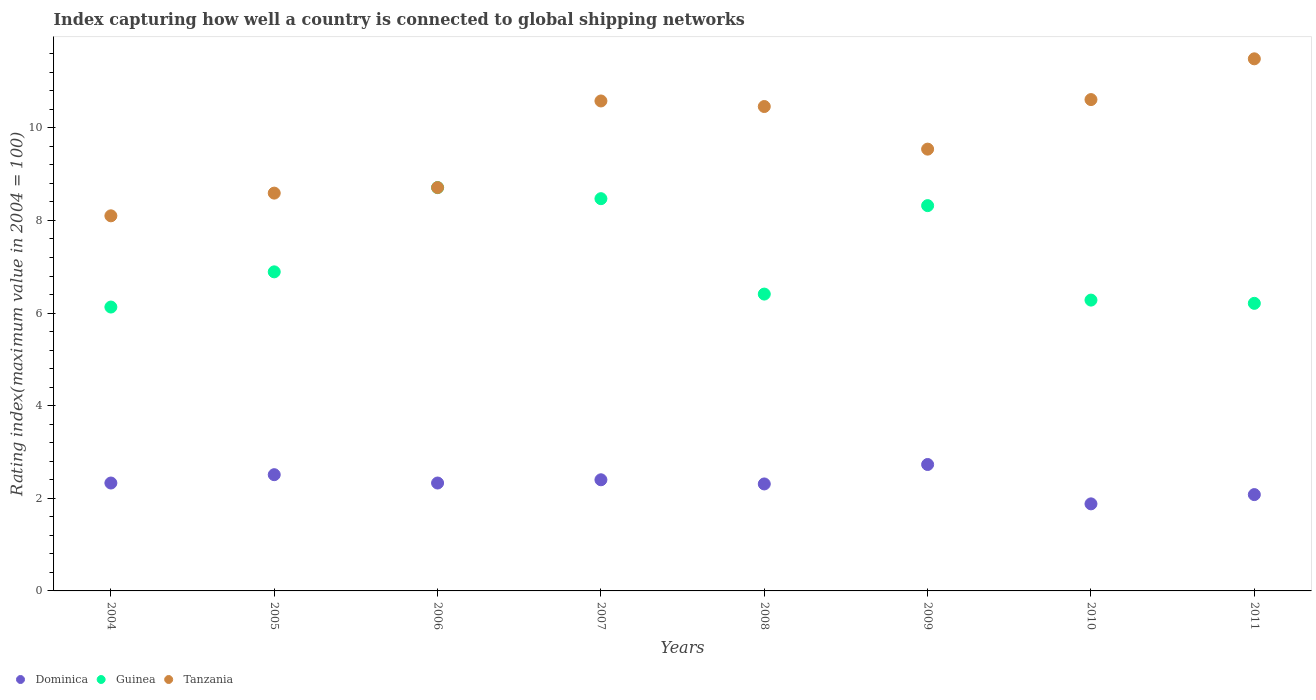How many different coloured dotlines are there?
Offer a terse response. 3. Is the number of dotlines equal to the number of legend labels?
Your answer should be compact. Yes. Across all years, what is the maximum rating index in Dominica?
Offer a very short reply. 2.73. Across all years, what is the minimum rating index in Guinea?
Make the answer very short. 6.13. In which year was the rating index in Guinea minimum?
Your answer should be very brief. 2004. What is the total rating index in Tanzania in the graph?
Keep it short and to the point. 78.08. What is the difference between the rating index in Tanzania in 2008 and that in 2011?
Your answer should be compact. -1.03. What is the difference between the rating index in Tanzania in 2006 and the rating index in Dominica in 2007?
Offer a terse response. 6.31. What is the average rating index in Tanzania per year?
Offer a terse response. 9.76. What is the ratio of the rating index in Guinea in 2006 to that in 2007?
Offer a terse response. 1.03. Is the rating index in Guinea in 2010 less than that in 2011?
Your answer should be compact. No. Is the difference between the rating index in Guinea in 2005 and 2011 greater than the difference between the rating index in Dominica in 2005 and 2011?
Make the answer very short. Yes. What is the difference between the highest and the second highest rating index in Guinea?
Your answer should be very brief. 0.24. What is the difference between the highest and the lowest rating index in Tanzania?
Ensure brevity in your answer.  3.39. In how many years, is the rating index in Dominica greater than the average rating index in Dominica taken over all years?
Your response must be concise. 5. Is it the case that in every year, the sum of the rating index in Dominica and rating index in Tanzania  is greater than the rating index in Guinea?
Offer a very short reply. Yes. Is the rating index in Guinea strictly less than the rating index in Dominica over the years?
Your answer should be very brief. No. How many years are there in the graph?
Ensure brevity in your answer.  8. What is the difference between two consecutive major ticks on the Y-axis?
Offer a very short reply. 2. Does the graph contain grids?
Keep it short and to the point. No. How are the legend labels stacked?
Provide a succinct answer. Horizontal. What is the title of the graph?
Offer a very short reply. Index capturing how well a country is connected to global shipping networks. What is the label or title of the Y-axis?
Keep it short and to the point. Rating index(maximum value in 2004 = 100). What is the Rating index(maximum value in 2004 = 100) in Dominica in 2004?
Provide a succinct answer. 2.33. What is the Rating index(maximum value in 2004 = 100) of Guinea in 2004?
Make the answer very short. 6.13. What is the Rating index(maximum value in 2004 = 100) of Tanzania in 2004?
Offer a very short reply. 8.1. What is the Rating index(maximum value in 2004 = 100) of Dominica in 2005?
Offer a very short reply. 2.51. What is the Rating index(maximum value in 2004 = 100) in Guinea in 2005?
Make the answer very short. 6.89. What is the Rating index(maximum value in 2004 = 100) in Tanzania in 2005?
Offer a terse response. 8.59. What is the Rating index(maximum value in 2004 = 100) in Dominica in 2006?
Keep it short and to the point. 2.33. What is the Rating index(maximum value in 2004 = 100) of Guinea in 2006?
Provide a short and direct response. 8.71. What is the Rating index(maximum value in 2004 = 100) in Tanzania in 2006?
Make the answer very short. 8.71. What is the Rating index(maximum value in 2004 = 100) in Dominica in 2007?
Offer a terse response. 2.4. What is the Rating index(maximum value in 2004 = 100) in Guinea in 2007?
Keep it short and to the point. 8.47. What is the Rating index(maximum value in 2004 = 100) of Tanzania in 2007?
Make the answer very short. 10.58. What is the Rating index(maximum value in 2004 = 100) of Dominica in 2008?
Ensure brevity in your answer.  2.31. What is the Rating index(maximum value in 2004 = 100) in Guinea in 2008?
Offer a very short reply. 6.41. What is the Rating index(maximum value in 2004 = 100) in Tanzania in 2008?
Your response must be concise. 10.46. What is the Rating index(maximum value in 2004 = 100) in Dominica in 2009?
Your answer should be very brief. 2.73. What is the Rating index(maximum value in 2004 = 100) in Guinea in 2009?
Your answer should be very brief. 8.32. What is the Rating index(maximum value in 2004 = 100) of Tanzania in 2009?
Give a very brief answer. 9.54. What is the Rating index(maximum value in 2004 = 100) of Dominica in 2010?
Offer a terse response. 1.88. What is the Rating index(maximum value in 2004 = 100) of Guinea in 2010?
Offer a terse response. 6.28. What is the Rating index(maximum value in 2004 = 100) of Tanzania in 2010?
Your answer should be compact. 10.61. What is the Rating index(maximum value in 2004 = 100) in Dominica in 2011?
Your answer should be very brief. 2.08. What is the Rating index(maximum value in 2004 = 100) in Guinea in 2011?
Your answer should be very brief. 6.21. What is the Rating index(maximum value in 2004 = 100) of Tanzania in 2011?
Your answer should be compact. 11.49. Across all years, what is the maximum Rating index(maximum value in 2004 = 100) of Dominica?
Keep it short and to the point. 2.73. Across all years, what is the maximum Rating index(maximum value in 2004 = 100) in Guinea?
Make the answer very short. 8.71. Across all years, what is the maximum Rating index(maximum value in 2004 = 100) of Tanzania?
Your answer should be very brief. 11.49. Across all years, what is the minimum Rating index(maximum value in 2004 = 100) of Dominica?
Offer a terse response. 1.88. Across all years, what is the minimum Rating index(maximum value in 2004 = 100) of Guinea?
Your answer should be compact. 6.13. What is the total Rating index(maximum value in 2004 = 100) in Dominica in the graph?
Make the answer very short. 18.57. What is the total Rating index(maximum value in 2004 = 100) of Guinea in the graph?
Provide a succinct answer. 57.42. What is the total Rating index(maximum value in 2004 = 100) in Tanzania in the graph?
Ensure brevity in your answer.  78.08. What is the difference between the Rating index(maximum value in 2004 = 100) of Dominica in 2004 and that in 2005?
Ensure brevity in your answer.  -0.18. What is the difference between the Rating index(maximum value in 2004 = 100) in Guinea in 2004 and that in 2005?
Your answer should be very brief. -0.76. What is the difference between the Rating index(maximum value in 2004 = 100) in Tanzania in 2004 and that in 2005?
Provide a succinct answer. -0.49. What is the difference between the Rating index(maximum value in 2004 = 100) of Dominica in 2004 and that in 2006?
Your answer should be very brief. 0. What is the difference between the Rating index(maximum value in 2004 = 100) in Guinea in 2004 and that in 2006?
Keep it short and to the point. -2.58. What is the difference between the Rating index(maximum value in 2004 = 100) of Tanzania in 2004 and that in 2006?
Ensure brevity in your answer.  -0.61. What is the difference between the Rating index(maximum value in 2004 = 100) in Dominica in 2004 and that in 2007?
Offer a terse response. -0.07. What is the difference between the Rating index(maximum value in 2004 = 100) of Guinea in 2004 and that in 2007?
Provide a short and direct response. -2.34. What is the difference between the Rating index(maximum value in 2004 = 100) of Tanzania in 2004 and that in 2007?
Provide a short and direct response. -2.48. What is the difference between the Rating index(maximum value in 2004 = 100) of Dominica in 2004 and that in 2008?
Ensure brevity in your answer.  0.02. What is the difference between the Rating index(maximum value in 2004 = 100) of Guinea in 2004 and that in 2008?
Offer a very short reply. -0.28. What is the difference between the Rating index(maximum value in 2004 = 100) in Tanzania in 2004 and that in 2008?
Keep it short and to the point. -2.36. What is the difference between the Rating index(maximum value in 2004 = 100) of Guinea in 2004 and that in 2009?
Your answer should be compact. -2.19. What is the difference between the Rating index(maximum value in 2004 = 100) of Tanzania in 2004 and that in 2009?
Offer a terse response. -1.44. What is the difference between the Rating index(maximum value in 2004 = 100) in Dominica in 2004 and that in 2010?
Provide a short and direct response. 0.45. What is the difference between the Rating index(maximum value in 2004 = 100) of Guinea in 2004 and that in 2010?
Ensure brevity in your answer.  -0.15. What is the difference between the Rating index(maximum value in 2004 = 100) in Tanzania in 2004 and that in 2010?
Make the answer very short. -2.51. What is the difference between the Rating index(maximum value in 2004 = 100) in Dominica in 2004 and that in 2011?
Keep it short and to the point. 0.25. What is the difference between the Rating index(maximum value in 2004 = 100) in Guinea in 2004 and that in 2011?
Provide a short and direct response. -0.08. What is the difference between the Rating index(maximum value in 2004 = 100) in Tanzania in 2004 and that in 2011?
Your answer should be compact. -3.39. What is the difference between the Rating index(maximum value in 2004 = 100) in Dominica in 2005 and that in 2006?
Ensure brevity in your answer.  0.18. What is the difference between the Rating index(maximum value in 2004 = 100) of Guinea in 2005 and that in 2006?
Provide a succinct answer. -1.82. What is the difference between the Rating index(maximum value in 2004 = 100) of Tanzania in 2005 and that in 2006?
Your answer should be compact. -0.12. What is the difference between the Rating index(maximum value in 2004 = 100) in Dominica in 2005 and that in 2007?
Provide a succinct answer. 0.11. What is the difference between the Rating index(maximum value in 2004 = 100) of Guinea in 2005 and that in 2007?
Your answer should be compact. -1.58. What is the difference between the Rating index(maximum value in 2004 = 100) of Tanzania in 2005 and that in 2007?
Offer a very short reply. -1.99. What is the difference between the Rating index(maximum value in 2004 = 100) of Guinea in 2005 and that in 2008?
Your answer should be very brief. 0.48. What is the difference between the Rating index(maximum value in 2004 = 100) in Tanzania in 2005 and that in 2008?
Your answer should be compact. -1.87. What is the difference between the Rating index(maximum value in 2004 = 100) in Dominica in 2005 and that in 2009?
Your response must be concise. -0.22. What is the difference between the Rating index(maximum value in 2004 = 100) in Guinea in 2005 and that in 2009?
Provide a short and direct response. -1.43. What is the difference between the Rating index(maximum value in 2004 = 100) in Tanzania in 2005 and that in 2009?
Provide a short and direct response. -0.95. What is the difference between the Rating index(maximum value in 2004 = 100) in Dominica in 2005 and that in 2010?
Keep it short and to the point. 0.63. What is the difference between the Rating index(maximum value in 2004 = 100) of Guinea in 2005 and that in 2010?
Your response must be concise. 0.61. What is the difference between the Rating index(maximum value in 2004 = 100) of Tanzania in 2005 and that in 2010?
Provide a short and direct response. -2.02. What is the difference between the Rating index(maximum value in 2004 = 100) in Dominica in 2005 and that in 2011?
Your answer should be very brief. 0.43. What is the difference between the Rating index(maximum value in 2004 = 100) in Guinea in 2005 and that in 2011?
Your answer should be compact. 0.68. What is the difference between the Rating index(maximum value in 2004 = 100) in Dominica in 2006 and that in 2007?
Offer a terse response. -0.07. What is the difference between the Rating index(maximum value in 2004 = 100) in Guinea in 2006 and that in 2007?
Offer a terse response. 0.24. What is the difference between the Rating index(maximum value in 2004 = 100) in Tanzania in 2006 and that in 2007?
Make the answer very short. -1.87. What is the difference between the Rating index(maximum value in 2004 = 100) in Dominica in 2006 and that in 2008?
Offer a very short reply. 0.02. What is the difference between the Rating index(maximum value in 2004 = 100) in Guinea in 2006 and that in 2008?
Keep it short and to the point. 2.3. What is the difference between the Rating index(maximum value in 2004 = 100) in Tanzania in 2006 and that in 2008?
Your answer should be compact. -1.75. What is the difference between the Rating index(maximum value in 2004 = 100) of Dominica in 2006 and that in 2009?
Offer a terse response. -0.4. What is the difference between the Rating index(maximum value in 2004 = 100) in Guinea in 2006 and that in 2009?
Offer a very short reply. 0.39. What is the difference between the Rating index(maximum value in 2004 = 100) in Tanzania in 2006 and that in 2009?
Keep it short and to the point. -0.83. What is the difference between the Rating index(maximum value in 2004 = 100) of Dominica in 2006 and that in 2010?
Ensure brevity in your answer.  0.45. What is the difference between the Rating index(maximum value in 2004 = 100) of Guinea in 2006 and that in 2010?
Keep it short and to the point. 2.43. What is the difference between the Rating index(maximum value in 2004 = 100) in Tanzania in 2006 and that in 2010?
Your response must be concise. -1.9. What is the difference between the Rating index(maximum value in 2004 = 100) of Dominica in 2006 and that in 2011?
Make the answer very short. 0.25. What is the difference between the Rating index(maximum value in 2004 = 100) in Guinea in 2006 and that in 2011?
Make the answer very short. 2.5. What is the difference between the Rating index(maximum value in 2004 = 100) in Tanzania in 2006 and that in 2011?
Provide a short and direct response. -2.78. What is the difference between the Rating index(maximum value in 2004 = 100) in Dominica in 2007 and that in 2008?
Provide a succinct answer. 0.09. What is the difference between the Rating index(maximum value in 2004 = 100) of Guinea in 2007 and that in 2008?
Provide a short and direct response. 2.06. What is the difference between the Rating index(maximum value in 2004 = 100) of Tanzania in 2007 and that in 2008?
Your answer should be very brief. 0.12. What is the difference between the Rating index(maximum value in 2004 = 100) in Dominica in 2007 and that in 2009?
Keep it short and to the point. -0.33. What is the difference between the Rating index(maximum value in 2004 = 100) in Guinea in 2007 and that in 2009?
Offer a very short reply. 0.15. What is the difference between the Rating index(maximum value in 2004 = 100) of Tanzania in 2007 and that in 2009?
Your answer should be compact. 1.04. What is the difference between the Rating index(maximum value in 2004 = 100) of Dominica in 2007 and that in 2010?
Make the answer very short. 0.52. What is the difference between the Rating index(maximum value in 2004 = 100) of Guinea in 2007 and that in 2010?
Offer a very short reply. 2.19. What is the difference between the Rating index(maximum value in 2004 = 100) in Tanzania in 2007 and that in 2010?
Provide a succinct answer. -0.03. What is the difference between the Rating index(maximum value in 2004 = 100) of Dominica in 2007 and that in 2011?
Provide a succinct answer. 0.32. What is the difference between the Rating index(maximum value in 2004 = 100) in Guinea in 2007 and that in 2011?
Your answer should be very brief. 2.26. What is the difference between the Rating index(maximum value in 2004 = 100) of Tanzania in 2007 and that in 2011?
Provide a succinct answer. -0.91. What is the difference between the Rating index(maximum value in 2004 = 100) of Dominica in 2008 and that in 2009?
Make the answer very short. -0.42. What is the difference between the Rating index(maximum value in 2004 = 100) of Guinea in 2008 and that in 2009?
Keep it short and to the point. -1.91. What is the difference between the Rating index(maximum value in 2004 = 100) of Tanzania in 2008 and that in 2009?
Give a very brief answer. 0.92. What is the difference between the Rating index(maximum value in 2004 = 100) in Dominica in 2008 and that in 2010?
Your answer should be very brief. 0.43. What is the difference between the Rating index(maximum value in 2004 = 100) in Guinea in 2008 and that in 2010?
Keep it short and to the point. 0.13. What is the difference between the Rating index(maximum value in 2004 = 100) in Dominica in 2008 and that in 2011?
Offer a terse response. 0.23. What is the difference between the Rating index(maximum value in 2004 = 100) in Tanzania in 2008 and that in 2011?
Offer a very short reply. -1.03. What is the difference between the Rating index(maximum value in 2004 = 100) in Guinea in 2009 and that in 2010?
Your answer should be very brief. 2.04. What is the difference between the Rating index(maximum value in 2004 = 100) in Tanzania in 2009 and that in 2010?
Ensure brevity in your answer.  -1.07. What is the difference between the Rating index(maximum value in 2004 = 100) in Dominica in 2009 and that in 2011?
Your response must be concise. 0.65. What is the difference between the Rating index(maximum value in 2004 = 100) of Guinea in 2009 and that in 2011?
Provide a short and direct response. 2.11. What is the difference between the Rating index(maximum value in 2004 = 100) in Tanzania in 2009 and that in 2011?
Make the answer very short. -1.95. What is the difference between the Rating index(maximum value in 2004 = 100) of Dominica in 2010 and that in 2011?
Your answer should be very brief. -0.2. What is the difference between the Rating index(maximum value in 2004 = 100) in Guinea in 2010 and that in 2011?
Offer a very short reply. 0.07. What is the difference between the Rating index(maximum value in 2004 = 100) of Tanzania in 2010 and that in 2011?
Give a very brief answer. -0.88. What is the difference between the Rating index(maximum value in 2004 = 100) of Dominica in 2004 and the Rating index(maximum value in 2004 = 100) of Guinea in 2005?
Your answer should be very brief. -4.56. What is the difference between the Rating index(maximum value in 2004 = 100) in Dominica in 2004 and the Rating index(maximum value in 2004 = 100) in Tanzania in 2005?
Offer a very short reply. -6.26. What is the difference between the Rating index(maximum value in 2004 = 100) of Guinea in 2004 and the Rating index(maximum value in 2004 = 100) of Tanzania in 2005?
Your response must be concise. -2.46. What is the difference between the Rating index(maximum value in 2004 = 100) in Dominica in 2004 and the Rating index(maximum value in 2004 = 100) in Guinea in 2006?
Provide a succinct answer. -6.38. What is the difference between the Rating index(maximum value in 2004 = 100) in Dominica in 2004 and the Rating index(maximum value in 2004 = 100) in Tanzania in 2006?
Ensure brevity in your answer.  -6.38. What is the difference between the Rating index(maximum value in 2004 = 100) in Guinea in 2004 and the Rating index(maximum value in 2004 = 100) in Tanzania in 2006?
Offer a terse response. -2.58. What is the difference between the Rating index(maximum value in 2004 = 100) of Dominica in 2004 and the Rating index(maximum value in 2004 = 100) of Guinea in 2007?
Your response must be concise. -6.14. What is the difference between the Rating index(maximum value in 2004 = 100) in Dominica in 2004 and the Rating index(maximum value in 2004 = 100) in Tanzania in 2007?
Offer a very short reply. -8.25. What is the difference between the Rating index(maximum value in 2004 = 100) in Guinea in 2004 and the Rating index(maximum value in 2004 = 100) in Tanzania in 2007?
Provide a short and direct response. -4.45. What is the difference between the Rating index(maximum value in 2004 = 100) in Dominica in 2004 and the Rating index(maximum value in 2004 = 100) in Guinea in 2008?
Give a very brief answer. -4.08. What is the difference between the Rating index(maximum value in 2004 = 100) in Dominica in 2004 and the Rating index(maximum value in 2004 = 100) in Tanzania in 2008?
Offer a very short reply. -8.13. What is the difference between the Rating index(maximum value in 2004 = 100) of Guinea in 2004 and the Rating index(maximum value in 2004 = 100) of Tanzania in 2008?
Provide a succinct answer. -4.33. What is the difference between the Rating index(maximum value in 2004 = 100) in Dominica in 2004 and the Rating index(maximum value in 2004 = 100) in Guinea in 2009?
Keep it short and to the point. -5.99. What is the difference between the Rating index(maximum value in 2004 = 100) of Dominica in 2004 and the Rating index(maximum value in 2004 = 100) of Tanzania in 2009?
Offer a very short reply. -7.21. What is the difference between the Rating index(maximum value in 2004 = 100) of Guinea in 2004 and the Rating index(maximum value in 2004 = 100) of Tanzania in 2009?
Provide a succinct answer. -3.41. What is the difference between the Rating index(maximum value in 2004 = 100) of Dominica in 2004 and the Rating index(maximum value in 2004 = 100) of Guinea in 2010?
Provide a short and direct response. -3.95. What is the difference between the Rating index(maximum value in 2004 = 100) of Dominica in 2004 and the Rating index(maximum value in 2004 = 100) of Tanzania in 2010?
Ensure brevity in your answer.  -8.28. What is the difference between the Rating index(maximum value in 2004 = 100) of Guinea in 2004 and the Rating index(maximum value in 2004 = 100) of Tanzania in 2010?
Offer a terse response. -4.48. What is the difference between the Rating index(maximum value in 2004 = 100) in Dominica in 2004 and the Rating index(maximum value in 2004 = 100) in Guinea in 2011?
Keep it short and to the point. -3.88. What is the difference between the Rating index(maximum value in 2004 = 100) in Dominica in 2004 and the Rating index(maximum value in 2004 = 100) in Tanzania in 2011?
Your answer should be very brief. -9.16. What is the difference between the Rating index(maximum value in 2004 = 100) in Guinea in 2004 and the Rating index(maximum value in 2004 = 100) in Tanzania in 2011?
Your response must be concise. -5.36. What is the difference between the Rating index(maximum value in 2004 = 100) of Dominica in 2005 and the Rating index(maximum value in 2004 = 100) of Guinea in 2006?
Your answer should be compact. -6.2. What is the difference between the Rating index(maximum value in 2004 = 100) of Dominica in 2005 and the Rating index(maximum value in 2004 = 100) of Tanzania in 2006?
Your answer should be compact. -6.2. What is the difference between the Rating index(maximum value in 2004 = 100) of Guinea in 2005 and the Rating index(maximum value in 2004 = 100) of Tanzania in 2006?
Provide a short and direct response. -1.82. What is the difference between the Rating index(maximum value in 2004 = 100) of Dominica in 2005 and the Rating index(maximum value in 2004 = 100) of Guinea in 2007?
Offer a terse response. -5.96. What is the difference between the Rating index(maximum value in 2004 = 100) of Dominica in 2005 and the Rating index(maximum value in 2004 = 100) of Tanzania in 2007?
Make the answer very short. -8.07. What is the difference between the Rating index(maximum value in 2004 = 100) of Guinea in 2005 and the Rating index(maximum value in 2004 = 100) of Tanzania in 2007?
Make the answer very short. -3.69. What is the difference between the Rating index(maximum value in 2004 = 100) of Dominica in 2005 and the Rating index(maximum value in 2004 = 100) of Tanzania in 2008?
Your response must be concise. -7.95. What is the difference between the Rating index(maximum value in 2004 = 100) of Guinea in 2005 and the Rating index(maximum value in 2004 = 100) of Tanzania in 2008?
Make the answer very short. -3.57. What is the difference between the Rating index(maximum value in 2004 = 100) in Dominica in 2005 and the Rating index(maximum value in 2004 = 100) in Guinea in 2009?
Keep it short and to the point. -5.81. What is the difference between the Rating index(maximum value in 2004 = 100) of Dominica in 2005 and the Rating index(maximum value in 2004 = 100) of Tanzania in 2009?
Provide a short and direct response. -7.03. What is the difference between the Rating index(maximum value in 2004 = 100) of Guinea in 2005 and the Rating index(maximum value in 2004 = 100) of Tanzania in 2009?
Keep it short and to the point. -2.65. What is the difference between the Rating index(maximum value in 2004 = 100) in Dominica in 2005 and the Rating index(maximum value in 2004 = 100) in Guinea in 2010?
Offer a terse response. -3.77. What is the difference between the Rating index(maximum value in 2004 = 100) of Guinea in 2005 and the Rating index(maximum value in 2004 = 100) of Tanzania in 2010?
Provide a short and direct response. -3.72. What is the difference between the Rating index(maximum value in 2004 = 100) of Dominica in 2005 and the Rating index(maximum value in 2004 = 100) of Guinea in 2011?
Your answer should be compact. -3.7. What is the difference between the Rating index(maximum value in 2004 = 100) of Dominica in 2005 and the Rating index(maximum value in 2004 = 100) of Tanzania in 2011?
Give a very brief answer. -8.98. What is the difference between the Rating index(maximum value in 2004 = 100) in Guinea in 2005 and the Rating index(maximum value in 2004 = 100) in Tanzania in 2011?
Keep it short and to the point. -4.6. What is the difference between the Rating index(maximum value in 2004 = 100) of Dominica in 2006 and the Rating index(maximum value in 2004 = 100) of Guinea in 2007?
Your answer should be compact. -6.14. What is the difference between the Rating index(maximum value in 2004 = 100) of Dominica in 2006 and the Rating index(maximum value in 2004 = 100) of Tanzania in 2007?
Make the answer very short. -8.25. What is the difference between the Rating index(maximum value in 2004 = 100) in Guinea in 2006 and the Rating index(maximum value in 2004 = 100) in Tanzania in 2007?
Make the answer very short. -1.87. What is the difference between the Rating index(maximum value in 2004 = 100) of Dominica in 2006 and the Rating index(maximum value in 2004 = 100) of Guinea in 2008?
Your answer should be very brief. -4.08. What is the difference between the Rating index(maximum value in 2004 = 100) in Dominica in 2006 and the Rating index(maximum value in 2004 = 100) in Tanzania in 2008?
Provide a succinct answer. -8.13. What is the difference between the Rating index(maximum value in 2004 = 100) of Guinea in 2006 and the Rating index(maximum value in 2004 = 100) of Tanzania in 2008?
Provide a short and direct response. -1.75. What is the difference between the Rating index(maximum value in 2004 = 100) of Dominica in 2006 and the Rating index(maximum value in 2004 = 100) of Guinea in 2009?
Keep it short and to the point. -5.99. What is the difference between the Rating index(maximum value in 2004 = 100) in Dominica in 2006 and the Rating index(maximum value in 2004 = 100) in Tanzania in 2009?
Your answer should be compact. -7.21. What is the difference between the Rating index(maximum value in 2004 = 100) of Guinea in 2006 and the Rating index(maximum value in 2004 = 100) of Tanzania in 2009?
Provide a short and direct response. -0.83. What is the difference between the Rating index(maximum value in 2004 = 100) of Dominica in 2006 and the Rating index(maximum value in 2004 = 100) of Guinea in 2010?
Offer a terse response. -3.95. What is the difference between the Rating index(maximum value in 2004 = 100) of Dominica in 2006 and the Rating index(maximum value in 2004 = 100) of Tanzania in 2010?
Make the answer very short. -8.28. What is the difference between the Rating index(maximum value in 2004 = 100) in Dominica in 2006 and the Rating index(maximum value in 2004 = 100) in Guinea in 2011?
Give a very brief answer. -3.88. What is the difference between the Rating index(maximum value in 2004 = 100) of Dominica in 2006 and the Rating index(maximum value in 2004 = 100) of Tanzania in 2011?
Your answer should be very brief. -9.16. What is the difference between the Rating index(maximum value in 2004 = 100) of Guinea in 2006 and the Rating index(maximum value in 2004 = 100) of Tanzania in 2011?
Provide a succinct answer. -2.78. What is the difference between the Rating index(maximum value in 2004 = 100) in Dominica in 2007 and the Rating index(maximum value in 2004 = 100) in Guinea in 2008?
Your answer should be very brief. -4.01. What is the difference between the Rating index(maximum value in 2004 = 100) in Dominica in 2007 and the Rating index(maximum value in 2004 = 100) in Tanzania in 2008?
Provide a succinct answer. -8.06. What is the difference between the Rating index(maximum value in 2004 = 100) of Guinea in 2007 and the Rating index(maximum value in 2004 = 100) of Tanzania in 2008?
Provide a short and direct response. -1.99. What is the difference between the Rating index(maximum value in 2004 = 100) of Dominica in 2007 and the Rating index(maximum value in 2004 = 100) of Guinea in 2009?
Ensure brevity in your answer.  -5.92. What is the difference between the Rating index(maximum value in 2004 = 100) of Dominica in 2007 and the Rating index(maximum value in 2004 = 100) of Tanzania in 2009?
Ensure brevity in your answer.  -7.14. What is the difference between the Rating index(maximum value in 2004 = 100) of Guinea in 2007 and the Rating index(maximum value in 2004 = 100) of Tanzania in 2009?
Provide a short and direct response. -1.07. What is the difference between the Rating index(maximum value in 2004 = 100) of Dominica in 2007 and the Rating index(maximum value in 2004 = 100) of Guinea in 2010?
Keep it short and to the point. -3.88. What is the difference between the Rating index(maximum value in 2004 = 100) of Dominica in 2007 and the Rating index(maximum value in 2004 = 100) of Tanzania in 2010?
Keep it short and to the point. -8.21. What is the difference between the Rating index(maximum value in 2004 = 100) in Guinea in 2007 and the Rating index(maximum value in 2004 = 100) in Tanzania in 2010?
Provide a succinct answer. -2.14. What is the difference between the Rating index(maximum value in 2004 = 100) in Dominica in 2007 and the Rating index(maximum value in 2004 = 100) in Guinea in 2011?
Ensure brevity in your answer.  -3.81. What is the difference between the Rating index(maximum value in 2004 = 100) of Dominica in 2007 and the Rating index(maximum value in 2004 = 100) of Tanzania in 2011?
Make the answer very short. -9.09. What is the difference between the Rating index(maximum value in 2004 = 100) of Guinea in 2007 and the Rating index(maximum value in 2004 = 100) of Tanzania in 2011?
Provide a short and direct response. -3.02. What is the difference between the Rating index(maximum value in 2004 = 100) of Dominica in 2008 and the Rating index(maximum value in 2004 = 100) of Guinea in 2009?
Make the answer very short. -6.01. What is the difference between the Rating index(maximum value in 2004 = 100) in Dominica in 2008 and the Rating index(maximum value in 2004 = 100) in Tanzania in 2009?
Offer a terse response. -7.23. What is the difference between the Rating index(maximum value in 2004 = 100) of Guinea in 2008 and the Rating index(maximum value in 2004 = 100) of Tanzania in 2009?
Keep it short and to the point. -3.13. What is the difference between the Rating index(maximum value in 2004 = 100) in Dominica in 2008 and the Rating index(maximum value in 2004 = 100) in Guinea in 2010?
Give a very brief answer. -3.97. What is the difference between the Rating index(maximum value in 2004 = 100) in Dominica in 2008 and the Rating index(maximum value in 2004 = 100) in Tanzania in 2010?
Keep it short and to the point. -8.3. What is the difference between the Rating index(maximum value in 2004 = 100) in Dominica in 2008 and the Rating index(maximum value in 2004 = 100) in Guinea in 2011?
Offer a very short reply. -3.9. What is the difference between the Rating index(maximum value in 2004 = 100) in Dominica in 2008 and the Rating index(maximum value in 2004 = 100) in Tanzania in 2011?
Keep it short and to the point. -9.18. What is the difference between the Rating index(maximum value in 2004 = 100) of Guinea in 2008 and the Rating index(maximum value in 2004 = 100) of Tanzania in 2011?
Provide a short and direct response. -5.08. What is the difference between the Rating index(maximum value in 2004 = 100) of Dominica in 2009 and the Rating index(maximum value in 2004 = 100) of Guinea in 2010?
Give a very brief answer. -3.55. What is the difference between the Rating index(maximum value in 2004 = 100) in Dominica in 2009 and the Rating index(maximum value in 2004 = 100) in Tanzania in 2010?
Your answer should be very brief. -7.88. What is the difference between the Rating index(maximum value in 2004 = 100) in Guinea in 2009 and the Rating index(maximum value in 2004 = 100) in Tanzania in 2010?
Provide a short and direct response. -2.29. What is the difference between the Rating index(maximum value in 2004 = 100) in Dominica in 2009 and the Rating index(maximum value in 2004 = 100) in Guinea in 2011?
Give a very brief answer. -3.48. What is the difference between the Rating index(maximum value in 2004 = 100) of Dominica in 2009 and the Rating index(maximum value in 2004 = 100) of Tanzania in 2011?
Provide a succinct answer. -8.76. What is the difference between the Rating index(maximum value in 2004 = 100) of Guinea in 2009 and the Rating index(maximum value in 2004 = 100) of Tanzania in 2011?
Keep it short and to the point. -3.17. What is the difference between the Rating index(maximum value in 2004 = 100) of Dominica in 2010 and the Rating index(maximum value in 2004 = 100) of Guinea in 2011?
Ensure brevity in your answer.  -4.33. What is the difference between the Rating index(maximum value in 2004 = 100) of Dominica in 2010 and the Rating index(maximum value in 2004 = 100) of Tanzania in 2011?
Offer a terse response. -9.61. What is the difference between the Rating index(maximum value in 2004 = 100) of Guinea in 2010 and the Rating index(maximum value in 2004 = 100) of Tanzania in 2011?
Give a very brief answer. -5.21. What is the average Rating index(maximum value in 2004 = 100) in Dominica per year?
Offer a very short reply. 2.32. What is the average Rating index(maximum value in 2004 = 100) of Guinea per year?
Make the answer very short. 7.18. What is the average Rating index(maximum value in 2004 = 100) of Tanzania per year?
Provide a succinct answer. 9.76. In the year 2004, what is the difference between the Rating index(maximum value in 2004 = 100) in Dominica and Rating index(maximum value in 2004 = 100) in Tanzania?
Your response must be concise. -5.77. In the year 2004, what is the difference between the Rating index(maximum value in 2004 = 100) in Guinea and Rating index(maximum value in 2004 = 100) in Tanzania?
Ensure brevity in your answer.  -1.97. In the year 2005, what is the difference between the Rating index(maximum value in 2004 = 100) of Dominica and Rating index(maximum value in 2004 = 100) of Guinea?
Offer a terse response. -4.38. In the year 2005, what is the difference between the Rating index(maximum value in 2004 = 100) of Dominica and Rating index(maximum value in 2004 = 100) of Tanzania?
Offer a terse response. -6.08. In the year 2005, what is the difference between the Rating index(maximum value in 2004 = 100) in Guinea and Rating index(maximum value in 2004 = 100) in Tanzania?
Keep it short and to the point. -1.7. In the year 2006, what is the difference between the Rating index(maximum value in 2004 = 100) of Dominica and Rating index(maximum value in 2004 = 100) of Guinea?
Your answer should be very brief. -6.38. In the year 2006, what is the difference between the Rating index(maximum value in 2004 = 100) in Dominica and Rating index(maximum value in 2004 = 100) in Tanzania?
Your answer should be very brief. -6.38. In the year 2007, what is the difference between the Rating index(maximum value in 2004 = 100) in Dominica and Rating index(maximum value in 2004 = 100) in Guinea?
Give a very brief answer. -6.07. In the year 2007, what is the difference between the Rating index(maximum value in 2004 = 100) of Dominica and Rating index(maximum value in 2004 = 100) of Tanzania?
Your answer should be very brief. -8.18. In the year 2007, what is the difference between the Rating index(maximum value in 2004 = 100) of Guinea and Rating index(maximum value in 2004 = 100) of Tanzania?
Offer a terse response. -2.11. In the year 2008, what is the difference between the Rating index(maximum value in 2004 = 100) in Dominica and Rating index(maximum value in 2004 = 100) in Tanzania?
Make the answer very short. -8.15. In the year 2008, what is the difference between the Rating index(maximum value in 2004 = 100) of Guinea and Rating index(maximum value in 2004 = 100) of Tanzania?
Ensure brevity in your answer.  -4.05. In the year 2009, what is the difference between the Rating index(maximum value in 2004 = 100) in Dominica and Rating index(maximum value in 2004 = 100) in Guinea?
Offer a very short reply. -5.59. In the year 2009, what is the difference between the Rating index(maximum value in 2004 = 100) in Dominica and Rating index(maximum value in 2004 = 100) in Tanzania?
Provide a succinct answer. -6.81. In the year 2009, what is the difference between the Rating index(maximum value in 2004 = 100) of Guinea and Rating index(maximum value in 2004 = 100) of Tanzania?
Ensure brevity in your answer.  -1.22. In the year 2010, what is the difference between the Rating index(maximum value in 2004 = 100) in Dominica and Rating index(maximum value in 2004 = 100) in Tanzania?
Offer a very short reply. -8.73. In the year 2010, what is the difference between the Rating index(maximum value in 2004 = 100) of Guinea and Rating index(maximum value in 2004 = 100) of Tanzania?
Your response must be concise. -4.33. In the year 2011, what is the difference between the Rating index(maximum value in 2004 = 100) of Dominica and Rating index(maximum value in 2004 = 100) of Guinea?
Provide a short and direct response. -4.13. In the year 2011, what is the difference between the Rating index(maximum value in 2004 = 100) of Dominica and Rating index(maximum value in 2004 = 100) of Tanzania?
Keep it short and to the point. -9.41. In the year 2011, what is the difference between the Rating index(maximum value in 2004 = 100) of Guinea and Rating index(maximum value in 2004 = 100) of Tanzania?
Provide a short and direct response. -5.28. What is the ratio of the Rating index(maximum value in 2004 = 100) of Dominica in 2004 to that in 2005?
Ensure brevity in your answer.  0.93. What is the ratio of the Rating index(maximum value in 2004 = 100) of Guinea in 2004 to that in 2005?
Your answer should be very brief. 0.89. What is the ratio of the Rating index(maximum value in 2004 = 100) in Tanzania in 2004 to that in 2005?
Offer a very short reply. 0.94. What is the ratio of the Rating index(maximum value in 2004 = 100) of Guinea in 2004 to that in 2006?
Keep it short and to the point. 0.7. What is the ratio of the Rating index(maximum value in 2004 = 100) in Dominica in 2004 to that in 2007?
Ensure brevity in your answer.  0.97. What is the ratio of the Rating index(maximum value in 2004 = 100) in Guinea in 2004 to that in 2007?
Keep it short and to the point. 0.72. What is the ratio of the Rating index(maximum value in 2004 = 100) of Tanzania in 2004 to that in 2007?
Offer a terse response. 0.77. What is the ratio of the Rating index(maximum value in 2004 = 100) in Dominica in 2004 to that in 2008?
Your answer should be compact. 1.01. What is the ratio of the Rating index(maximum value in 2004 = 100) in Guinea in 2004 to that in 2008?
Provide a succinct answer. 0.96. What is the ratio of the Rating index(maximum value in 2004 = 100) in Tanzania in 2004 to that in 2008?
Your response must be concise. 0.77. What is the ratio of the Rating index(maximum value in 2004 = 100) in Dominica in 2004 to that in 2009?
Offer a very short reply. 0.85. What is the ratio of the Rating index(maximum value in 2004 = 100) of Guinea in 2004 to that in 2009?
Keep it short and to the point. 0.74. What is the ratio of the Rating index(maximum value in 2004 = 100) in Tanzania in 2004 to that in 2009?
Your answer should be very brief. 0.85. What is the ratio of the Rating index(maximum value in 2004 = 100) of Dominica in 2004 to that in 2010?
Provide a short and direct response. 1.24. What is the ratio of the Rating index(maximum value in 2004 = 100) in Guinea in 2004 to that in 2010?
Your response must be concise. 0.98. What is the ratio of the Rating index(maximum value in 2004 = 100) of Tanzania in 2004 to that in 2010?
Provide a short and direct response. 0.76. What is the ratio of the Rating index(maximum value in 2004 = 100) of Dominica in 2004 to that in 2011?
Give a very brief answer. 1.12. What is the ratio of the Rating index(maximum value in 2004 = 100) in Guinea in 2004 to that in 2011?
Your response must be concise. 0.99. What is the ratio of the Rating index(maximum value in 2004 = 100) in Tanzania in 2004 to that in 2011?
Keep it short and to the point. 0.7. What is the ratio of the Rating index(maximum value in 2004 = 100) of Dominica in 2005 to that in 2006?
Provide a succinct answer. 1.08. What is the ratio of the Rating index(maximum value in 2004 = 100) of Guinea in 2005 to that in 2006?
Your answer should be compact. 0.79. What is the ratio of the Rating index(maximum value in 2004 = 100) in Tanzania in 2005 to that in 2006?
Keep it short and to the point. 0.99. What is the ratio of the Rating index(maximum value in 2004 = 100) of Dominica in 2005 to that in 2007?
Provide a succinct answer. 1.05. What is the ratio of the Rating index(maximum value in 2004 = 100) in Guinea in 2005 to that in 2007?
Your answer should be very brief. 0.81. What is the ratio of the Rating index(maximum value in 2004 = 100) in Tanzania in 2005 to that in 2007?
Give a very brief answer. 0.81. What is the ratio of the Rating index(maximum value in 2004 = 100) in Dominica in 2005 to that in 2008?
Offer a very short reply. 1.09. What is the ratio of the Rating index(maximum value in 2004 = 100) in Guinea in 2005 to that in 2008?
Offer a very short reply. 1.07. What is the ratio of the Rating index(maximum value in 2004 = 100) in Tanzania in 2005 to that in 2008?
Make the answer very short. 0.82. What is the ratio of the Rating index(maximum value in 2004 = 100) in Dominica in 2005 to that in 2009?
Offer a terse response. 0.92. What is the ratio of the Rating index(maximum value in 2004 = 100) of Guinea in 2005 to that in 2009?
Provide a succinct answer. 0.83. What is the ratio of the Rating index(maximum value in 2004 = 100) in Tanzania in 2005 to that in 2009?
Ensure brevity in your answer.  0.9. What is the ratio of the Rating index(maximum value in 2004 = 100) of Dominica in 2005 to that in 2010?
Keep it short and to the point. 1.34. What is the ratio of the Rating index(maximum value in 2004 = 100) in Guinea in 2005 to that in 2010?
Make the answer very short. 1.1. What is the ratio of the Rating index(maximum value in 2004 = 100) in Tanzania in 2005 to that in 2010?
Provide a short and direct response. 0.81. What is the ratio of the Rating index(maximum value in 2004 = 100) of Dominica in 2005 to that in 2011?
Provide a short and direct response. 1.21. What is the ratio of the Rating index(maximum value in 2004 = 100) of Guinea in 2005 to that in 2011?
Ensure brevity in your answer.  1.11. What is the ratio of the Rating index(maximum value in 2004 = 100) in Tanzania in 2005 to that in 2011?
Your answer should be very brief. 0.75. What is the ratio of the Rating index(maximum value in 2004 = 100) in Dominica in 2006 to that in 2007?
Make the answer very short. 0.97. What is the ratio of the Rating index(maximum value in 2004 = 100) in Guinea in 2006 to that in 2007?
Keep it short and to the point. 1.03. What is the ratio of the Rating index(maximum value in 2004 = 100) of Tanzania in 2006 to that in 2007?
Provide a succinct answer. 0.82. What is the ratio of the Rating index(maximum value in 2004 = 100) of Dominica in 2006 to that in 2008?
Your answer should be very brief. 1.01. What is the ratio of the Rating index(maximum value in 2004 = 100) in Guinea in 2006 to that in 2008?
Offer a very short reply. 1.36. What is the ratio of the Rating index(maximum value in 2004 = 100) in Tanzania in 2006 to that in 2008?
Provide a succinct answer. 0.83. What is the ratio of the Rating index(maximum value in 2004 = 100) of Dominica in 2006 to that in 2009?
Provide a short and direct response. 0.85. What is the ratio of the Rating index(maximum value in 2004 = 100) of Guinea in 2006 to that in 2009?
Offer a terse response. 1.05. What is the ratio of the Rating index(maximum value in 2004 = 100) of Tanzania in 2006 to that in 2009?
Your response must be concise. 0.91. What is the ratio of the Rating index(maximum value in 2004 = 100) in Dominica in 2006 to that in 2010?
Your answer should be compact. 1.24. What is the ratio of the Rating index(maximum value in 2004 = 100) in Guinea in 2006 to that in 2010?
Ensure brevity in your answer.  1.39. What is the ratio of the Rating index(maximum value in 2004 = 100) of Tanzania in 2006 to that in 2010?
Offer a very short reply. 0.82. What is the ratio of the Rating index(maximum value in 2004 = 100) of Dominica in 2006 to that in 2011?
Give a very brief answer. 1.12. What is the ratio of the Rating index(maximum value in 2004 = 100) of Guinea in 2006 to that in 2011?
Make the answer very short. 1.4. What is the ratio of the Rating index(maximum value in 2004 = 100) in Tanzania in 2006 to that in 2011?
Your response must be concise. 0.76. What is the ratio of the Rating index(maximum value in 2004 = 100) of Dominica in 2007 to that in 2008?
Offer a terse response. 1.04. What is the ratio of the Rating index(maximum value in 2004 = 100) in Guinea in 2007 to that in 2008?
Provide a succinct answer. 1.32. What is the ratio of the Rating index(maximum value in 2004 = 100) of Tanzania in 2007 to that in 2008?
Keep it short and to the point. 1.01. What is the ratio of the Rating index(maximum value in 2004 = 100) of Dominica in 2007 to that in 2009?
Make the answer very short. 0.88. What is the ratio of the Rating index(maximum value in 2004 = 100) in Guinea in 2007 to that in 2009?
Offer a terse response. 1.02. What is the ratio of the Rating index(maximum value in 2004 = 100) in Tanzania in 2007 to that in 2009?
Keep it short and to the point. 1.11. What is the ratio of the Rating index(maximum value in 2004 = 100) of Dominica in 2007 to that in 2010?
Give a very brief answer. 1.28. What is the ratio of the Rating index(maximum value in 2004 = 100) in Guinea in 2007 to that in 2010?
Make the answer very short. 1.35. What is the ratio of the Rating index(maximum value in 2004 = 100) of Dominica in 2007 to that in 2011?
Your answer should be compact. 1.15. What is the ratio of the Rating index(maximum value in 2004 = 100) of Guinea in 2007 to that in 2011?
Offer a terse response. 1.36. What is the ratio of the Rating index(maximum value in 2004 = 100) in Tanzania in 2007 to that in 2011?
Your answer should be compact. 0.92. What is the ratio of the Rating index(maximum value in 2004 = 100) in Dominica in 2008 to that in 2009?
Your answer should be very brief. 0.85. What is the ratio of the Rating index(maximum value in 2004 = 100) in Guinea in 2008 to that in 2009?
Your answer should be compact. 0.77. What is the ratio of the Rating index(maximum value in 2004 = 100) of Tanzania in 2008 to that in 2009?
Ensure brevity in your answer.  1.1. What is the ratio of the Rating index(maximum value in 2004 = 100) in Dominica in 2008 to that in 2010?
Ensure brevity in your answer.  1.23. What is the ratio of the Rating index(maximum value in 2004 = 100) in Guinea in 2008 to that in 2010?
Ensure brevity in your answer.  1.02. What is the ratio of the Rating index(maximum value in 2004 = 100) in Tanzania in 2008 to that in 2010?
Offer a terse response. 0.99. What is the ratio of the Rating index(maximum value in 2004 = 100) of Dominica in 2008 to that in 2011?
Your answer should be compact. 1.11. What is the ratio of the Rating index(maximum value in 2004 = 100) of Guinea in 2008 to that in 2011?
Provide a succinct answer. 1.03. What is the ratio of the Rating index(maximum value in 2004 = 100) in Tanzania in 2008 to that in 2011?
Provide a succinct answer. 0.91. What is the ratio of the Rating index(maximum value in 2004 = 100) of Dominica in 2009 to that in 2010?
Provide a short and direct response. 1.45. What is the ratio of the Rating index(maximum value in 2004 = 100) of Guinea in 2009 to that in 2010?
Your answer should be very brief. 1.32. What is the ratio of the Rating index(maximum value in 2004 = 100) in Tanzania in 2009 to that in 2010?
Offer a very short reply. 0.9. What is the ratio of the Rating index(maximum value in 2004 = 100) of Dominica in 2009 to that in 2011?
Provide a short and direct response. 1.31. What is the ratio of the Rating index(maximum value in 2004 = 100) of Guinea in 2009 to that in 2011?
Your response must be concise. 1.34. What is the ratio of the Rating index(maximum value in 2004 = 100) in Tanzania in 2009 to that in 2011?
Your answer should be very brief. 0.83. What is the ratio of the Rating index(maximum value in 2004 = 100) in Dominica in 2010 to that in 2011?
Keep it short and to the point. 0.9. What is the ratio of the Rating index(maximum value in 2004 = 100) of Guinea in 2010 to that in 2011?
Give a very brief answer. 1.01. What is the ratio of the Rating index(maximum value in 2004 = 100) of Tanzania in 2010 to that in 2011?
Make the answer very short. 0.92. What is the difference between the highest and the second highest Rating index(maximum value in 2004 = 100) of Dominica?
Ensure brevity in your answer.  0.22. What is the difference between the highest and the second highest Rating index(maximum value in 2004 = 100) of Guinea?
Your answer should be very brief. 0.24. What is the difference between the highest and the second highest Rating index(maximum value in 2004 = 100) in Tanzania?
Your response must be concise. 0.88. What is the difference between the highest and the lowest Rating index(maximum value in 2004 = 100) in Dominica?
Make the answer very short. 0.85. What is the difference between the highest and the lowest Rating index(maximum value in 2004 = 100) of Guinea?
Your answer should be compact. 2.58. What is the difference between the highest and the lowest Rating index(maximum value in 2004 = 100) in Tanzania?
Give a very brief answer. 3.39. 